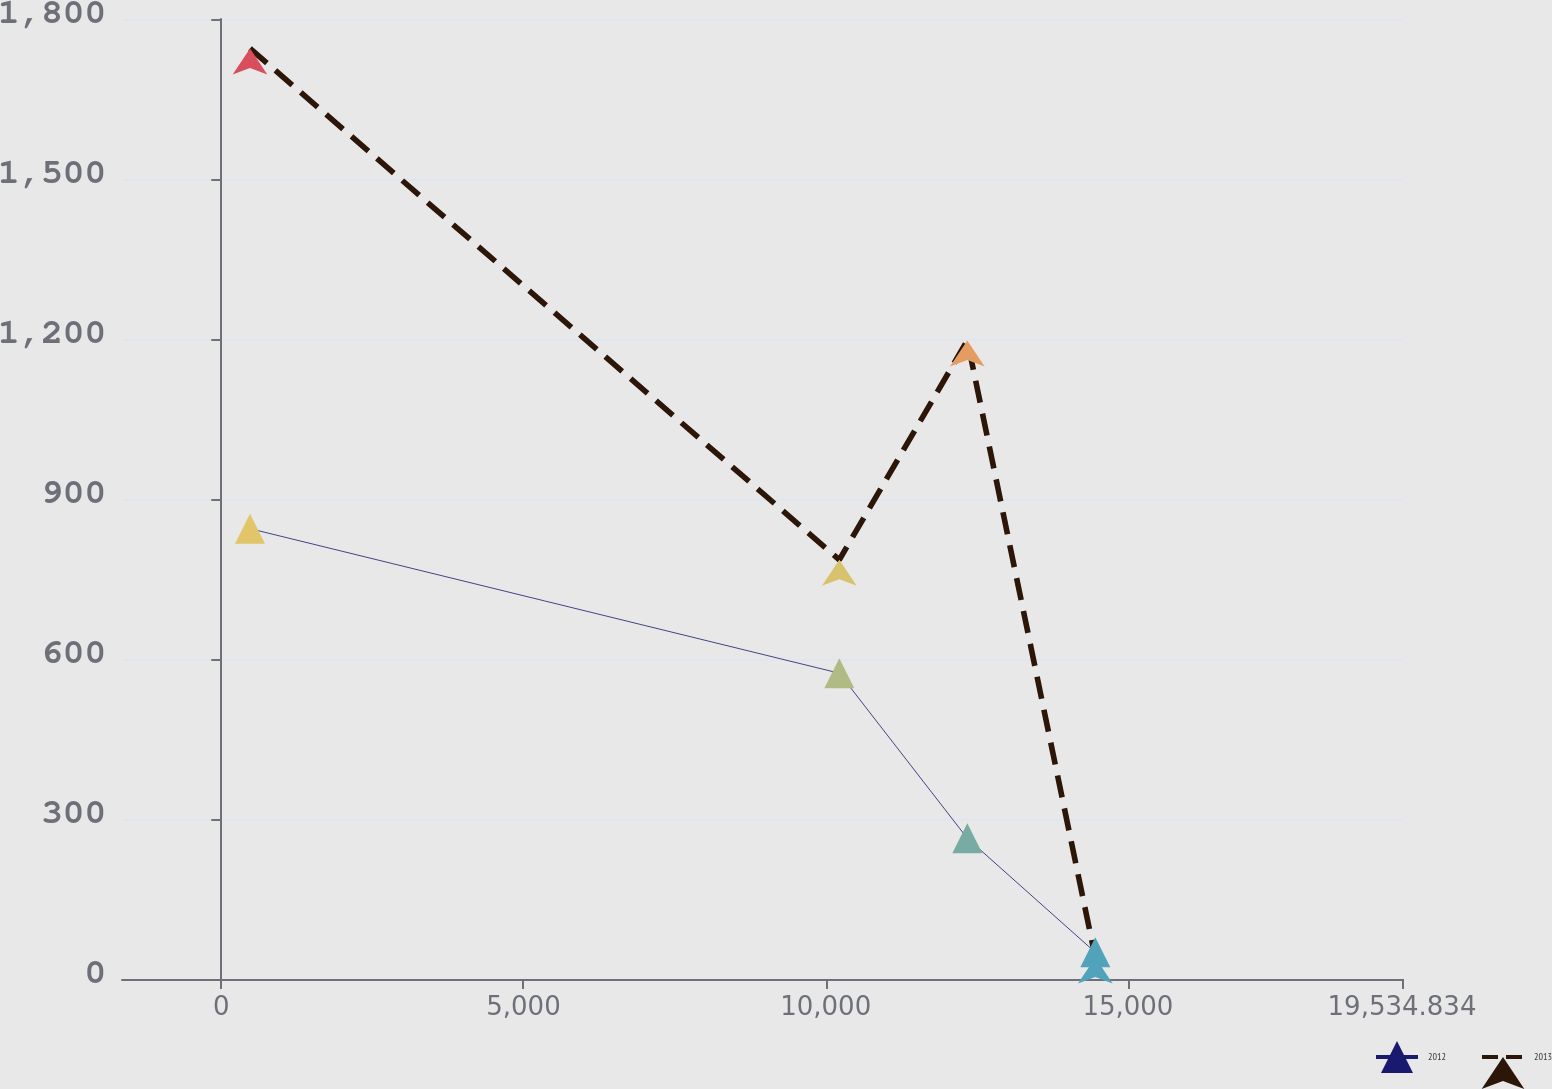<chart> <loc_0><loc_0><loc_500><loc_500><line_chart><ecel><fcel>2012<fcel>2013<nl><fcel>475.21<fcel>844.39<fcel>1744.92<nl><fcel>10225.4<fcel>573.35<fcel>786.05<nl><fcel>12343.1<fcel>263.77<fcel>1197.16<nl><fcel>14460.8<fcel>49.95<fcel>40.18<nl><fcel>21652.6<fcel>184.33<fcel>1026.69<nl></chart> 